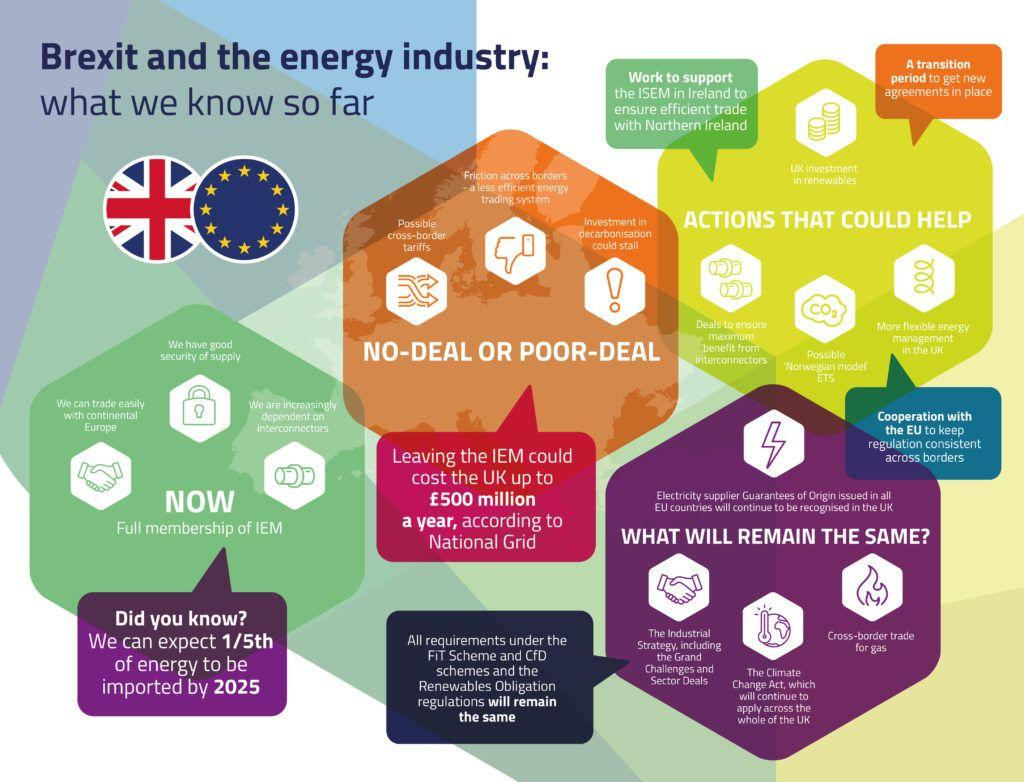Identify some key points in this picture. The symbol of fire represents cross-border trade for gas. The Climate Change Act will remain unchanged for the UK after Brexit. The flag with stars belongs to the European Union (EU). In this image, there are two flags on display. Four images of large hexagons are depicted. 